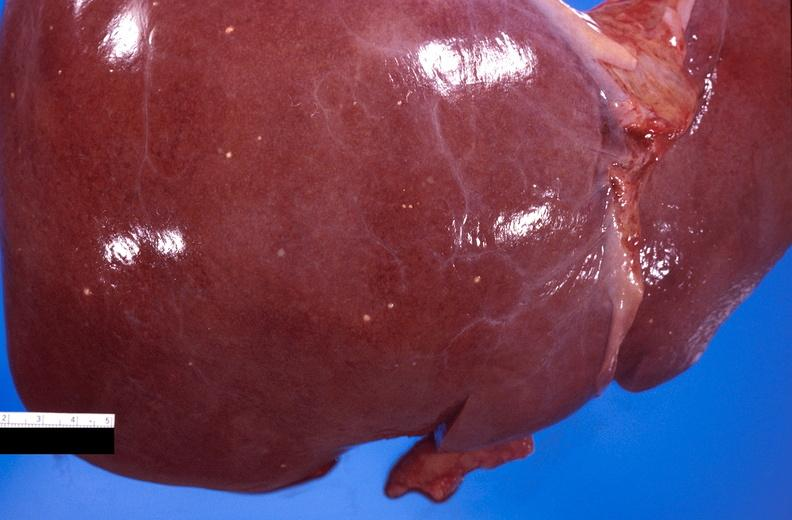what does this image show?
Answer the question using a single word or phrase. Liver 